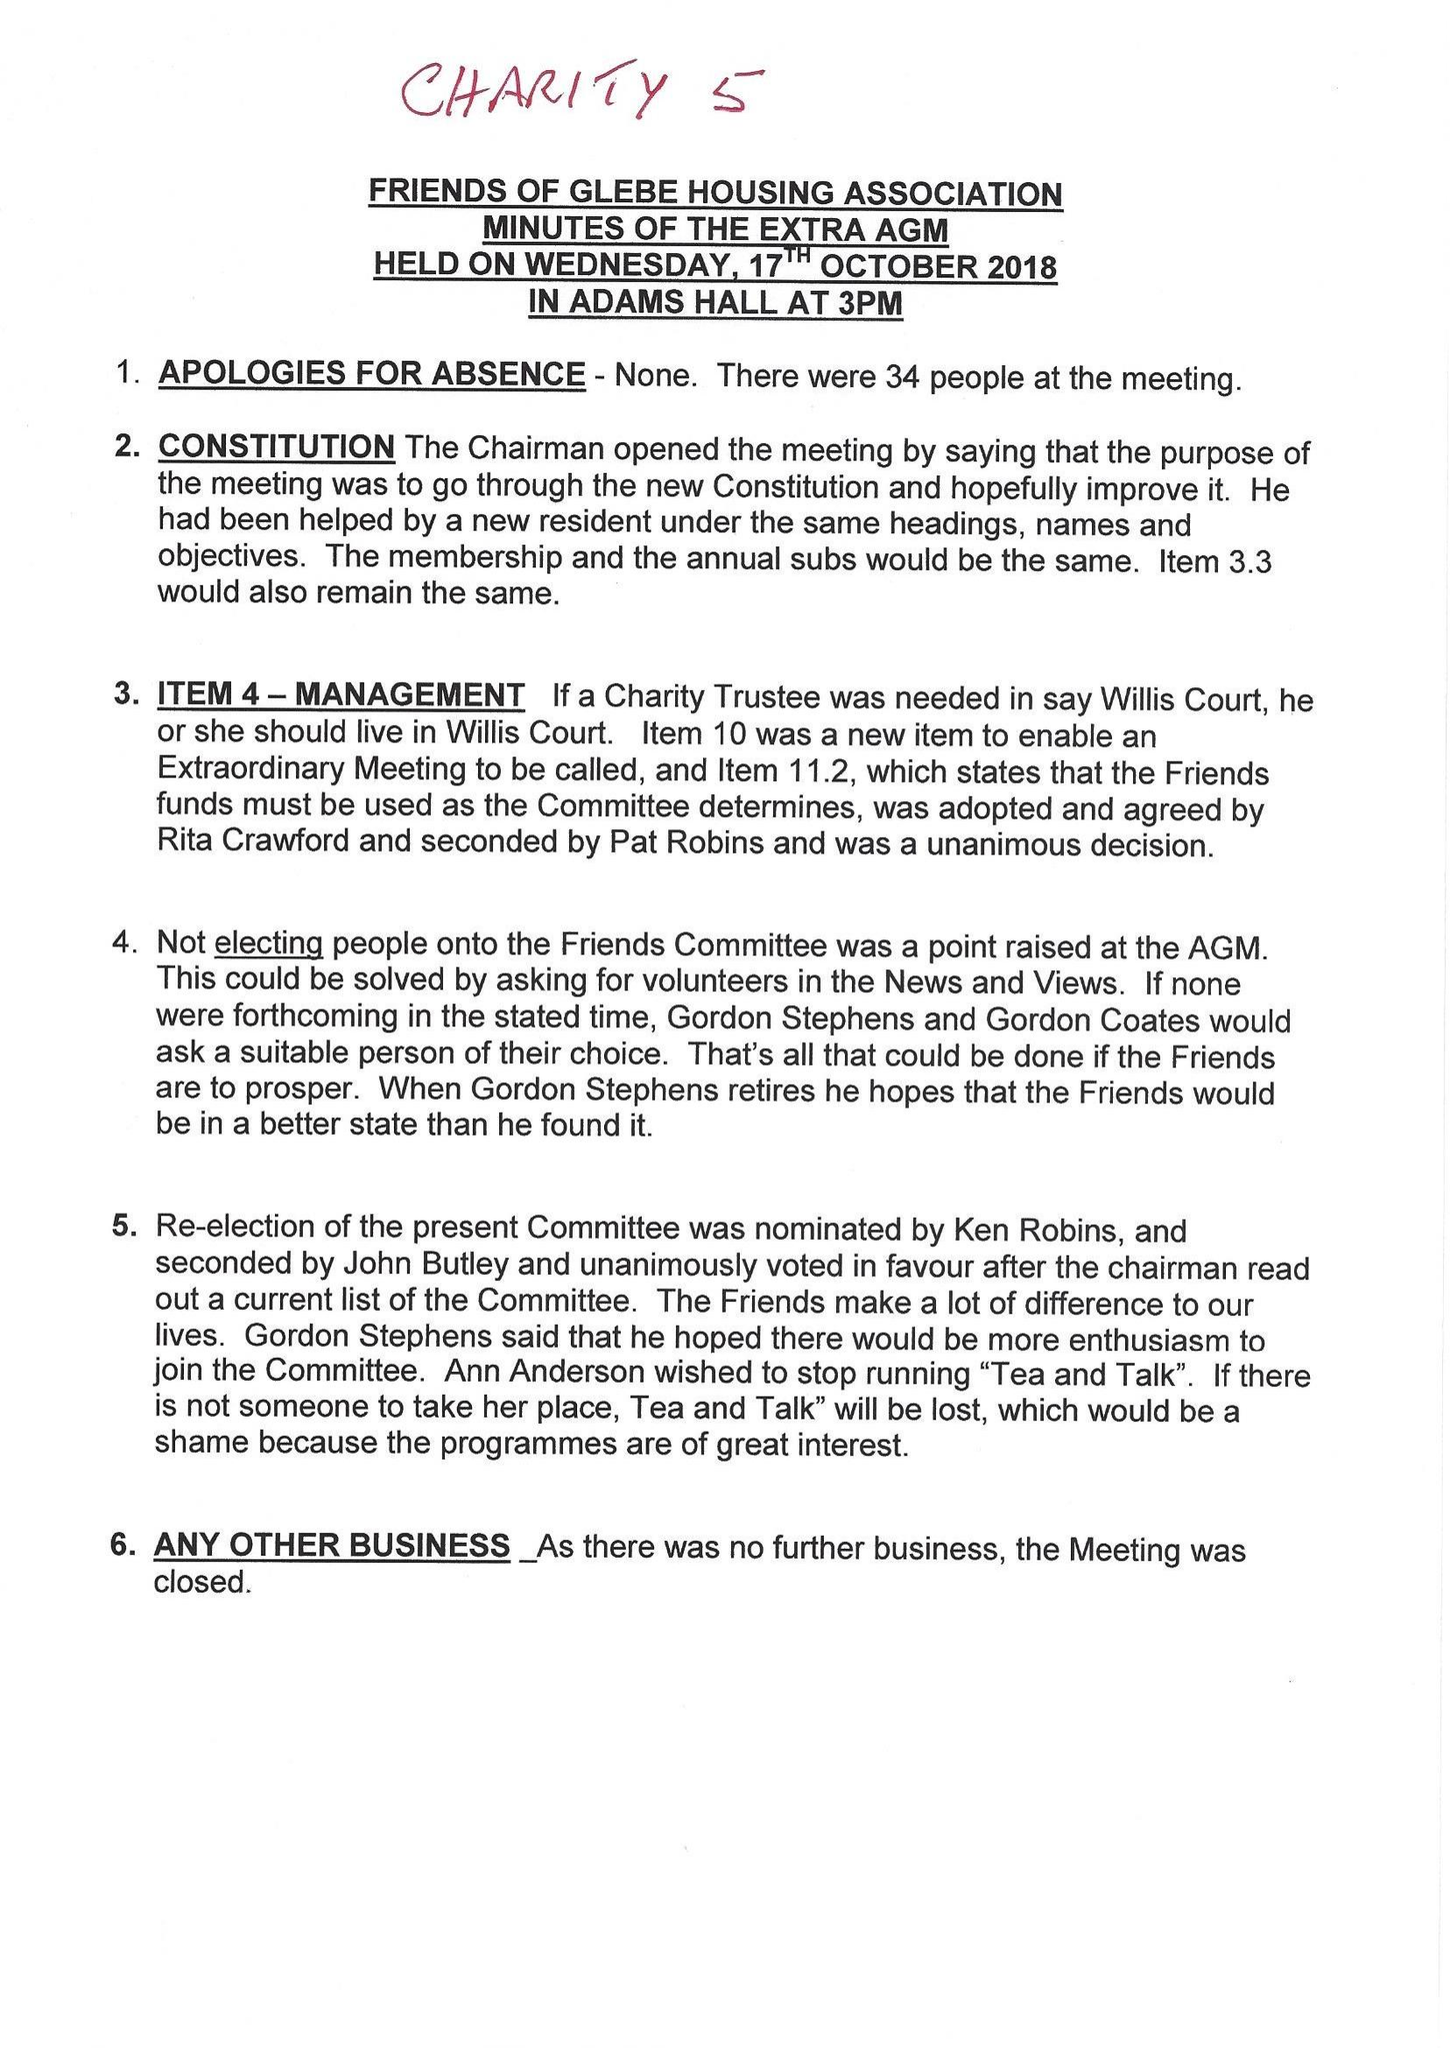What is the value for the address__postcode?
Answer the question using a single word or phrase. BR4 9QD 